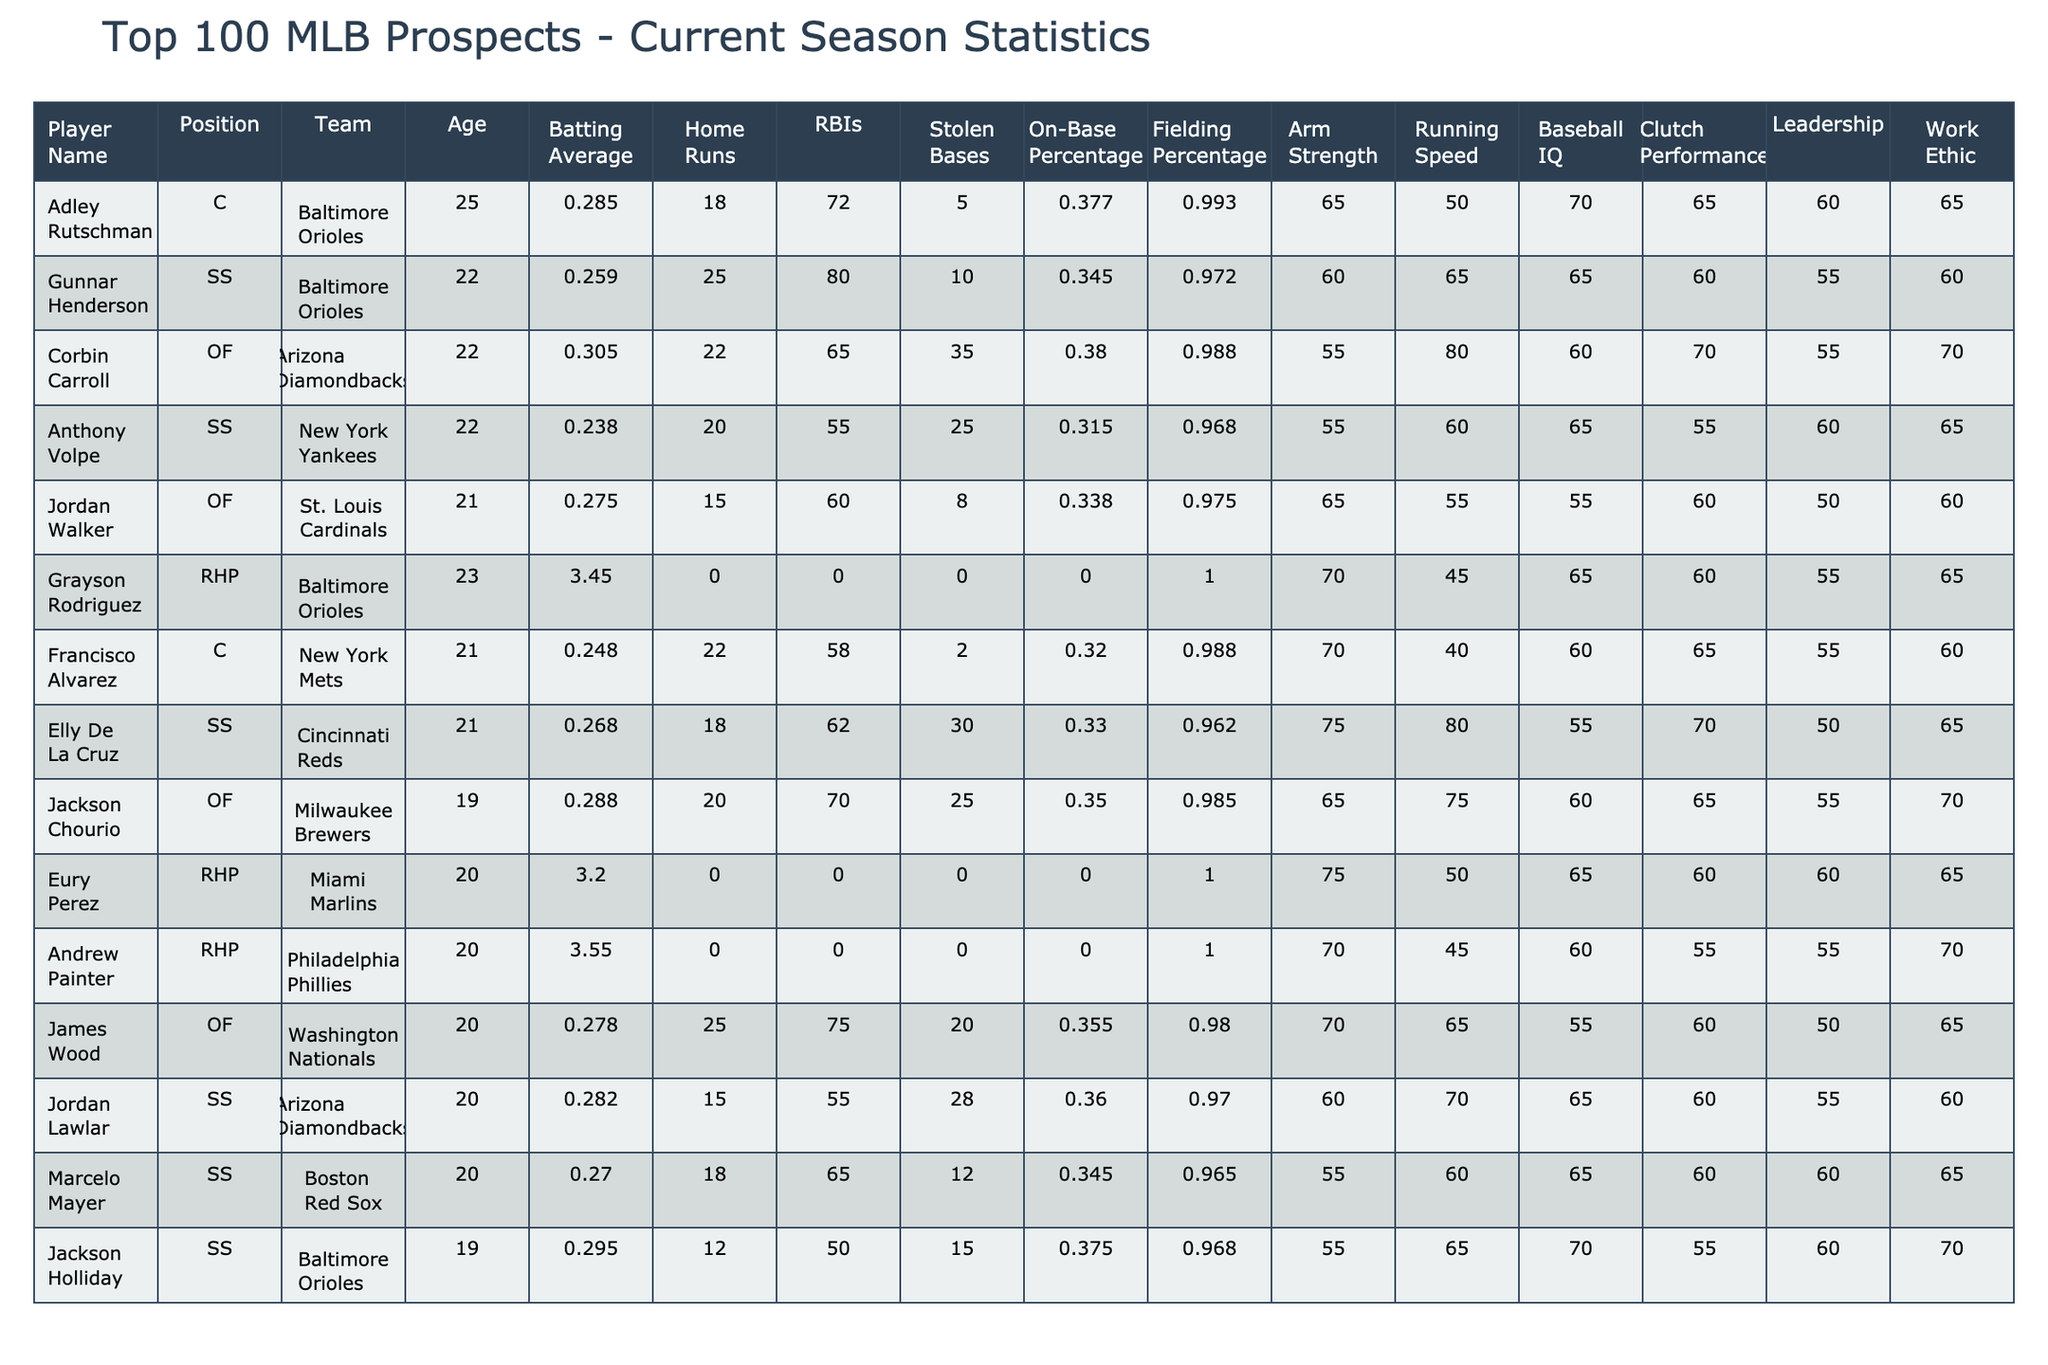What is the batting average of Corbin Carroll? The table lists Corbin Carroll's batting average as 0.305, which can be found in the corresponding row of the table under "Batting Average."
Answer: 0.305 Which player has the highest number of home runs? Reviewing the "Home Runs" column, Gunnar Henderson has the highest number of home runs at 25.
Answer: Gunnar Henderson What is the difference in RBIs between Adley Rutschman and Francisco Alvarez? Adley Rutschman has 72 RBIs while Francisco Alvarez has 58 RBIs. The difference is 72 - 58 = 14.
Answer: 14 Is Eury Perez a catcher? Eury Perez is listed as a right-handed pitcher (RHP) in the "Position" column, not a catcher.
Answer: No What is the average on-base percentage of players from the Baltimore Orioles? The Orioles have three players: Adley Rutschman (0.377), Gunnar Henderson (0.345), and Jackson Holliday (0.375). Summing these gives 0.377 + 0.345 + 0.375 = 1.097. Dividing by 3 gives an average of 1.097 / 3 = 0.366.
Answer: 0.366 Which player has the highest fielding percentage, and what is it? The table indicates that Grayson Rodriguez has a fielding percentage of 1.000, which is the highest among the listed players.
Answer: Grayson Rodriguez, 1.000 What is the total number of stolen bases for all players? By summing the "Stolen Bases" column: 5 + 10 + 35 + 25 + 8 + 0 + 2 + 30 + 25 + 0 + 0 + 20 + 28 + 12 = 175.
Answer: 175 Which player is older, Jackson Chourio or Jordan Lawlar? Jackson Chourio is 19 years old and Jordan Lawlar is 20 years old. Since 20 is greater than 19, Jordan Lawlar is older.
Answer: Jordan Lawlar What is the average Arm Strength for outfield players? The outfield players are Corbin Carroll (55), Jordan Walker (65), Elly De La Cruz (75), Jackson Chourio (65), James Wood (70). The sum is 55 + 65 + 75 + 65 + 70 = 330. Dividing by 5 gives 330 / 5 = 66.
Answer: 66 How many players have a running speed greater than 70? The players with running speeds greater than 70 are Corbin Carroll (80), Elly De La Cruz (80), and Jackson Chourio (75). Thus, there are 3 players.
Answer: 3 